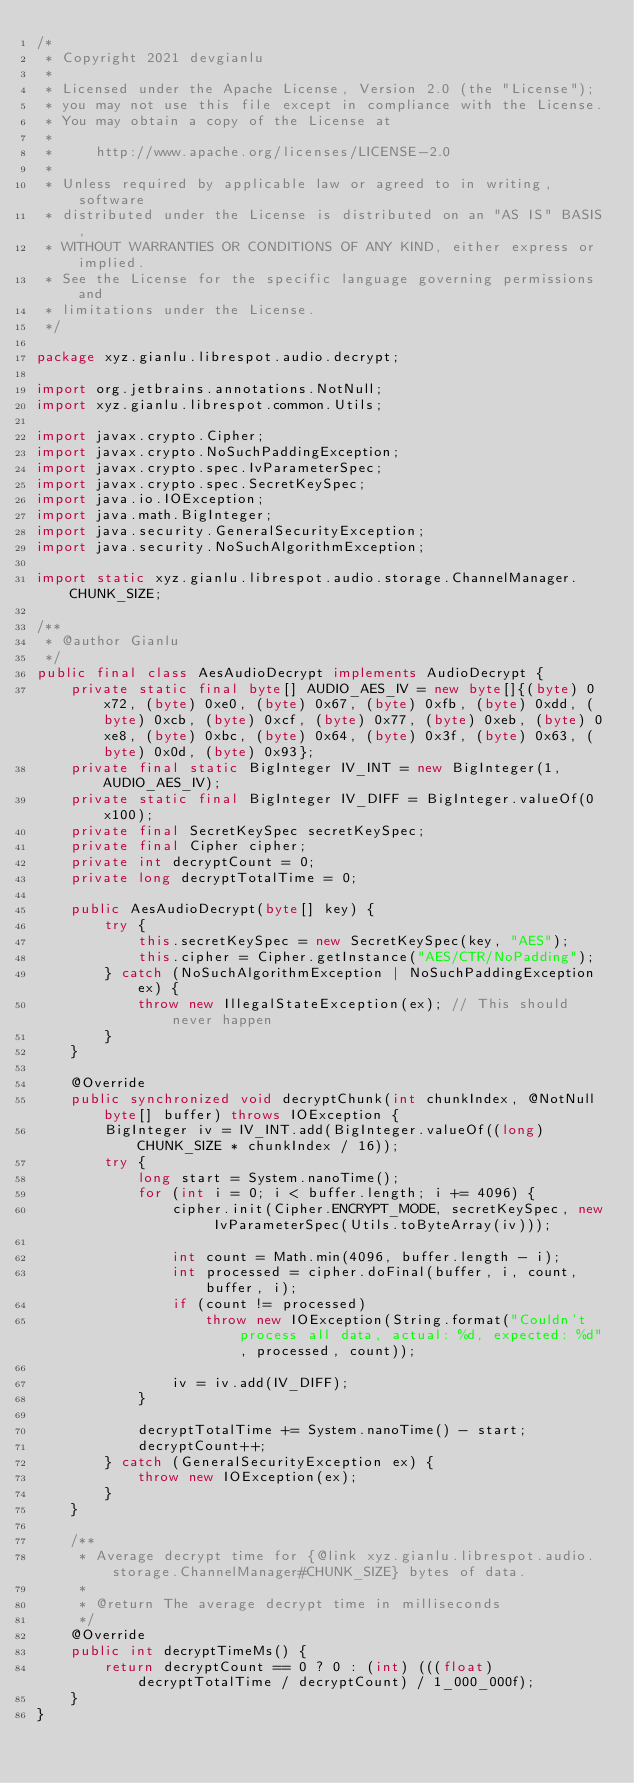<code> <loc_0><loc_0><loc_500><loc_500><_Java_>/*
 * Copyright 2021 devgianlu
 *
 * Licensed under the Apache License, Version 2.0 (the "License");
 * you may not use this file except in compliance with the License.
 * You may obtain a copy of the License at
 *
 *     http://www.apache.org/licenses/LICENSE-2.0
 *
 * Unless required by applicable law or agreed to in writing, software
 * distributed under the License is distributed on an "AS IS" BASIS,
 * WITHOUT WARRANTIES OR CONDITIONS OF ANY KIND, either express or implied.
 * See the License for the specific language governing permissions and
 * limitations under the License.
 */

package xyz.gianlu.librespot.audio.decrypt;

import org.jetbrains.annotations.NotNull;
import xyz.gianlu.librespot.common.Utils;

import javax.crypto.Cipher;
import javax.crypto.NoSuchPaddingException;
import javax.crypto.spec.IvParameterSpec;
import javax.crypto.spec.SecretKeySpec;
import java.io.IOException;
import java.math.BigInteger;
import java.security.GeneralSecurityException;
import java.security.NoSuchAlgorithmException;

import static xyz.gianlu.librespot.audio.storage.ChannelManager.CHUNK_SIZE;

/**
 * @author Gianlu
 */
public final class AesAudioDecrypt implements AudioDecrypt {
    private static final byte[] AUDIO_AES_IV = new byte[]{(byte) 0x72, (byte) 0xe0, (byte) 0x67, (byte) 0xfb, (byte) 0xdd, (byte) 0xcb, (byte) 0xcf, (byte) 0x77, (byte) 0xeb, (byte) 0xe8, (byte) 0xbc, (byte) 0x64, (byte) 0x3f, (byte) 0x63, (byte) 0x0d, (byte) 0x93};
    private final static BigInteger IV_INT = new BigInteger(1, AUDIO_AES_IV);
    private static final BigInteger IV_DIFF = BigInteger.valueOf(0x100);
    private final SecretKeySpec secretKeySpec;
    private final Cipher cipher;
    private int decryptCount = 0;
    private long decryptTotalTime = 0;

    public AesAudioDecrypt(byte[] key) {
        try {
            this.secretKeySpec = new SecretKeySpec(key, "AES");
            this.cipher = Cipher.getInstance("AES/CTR/NoPadding");
        } catch (NoSuchAlgorithmException | NoSuchPaddingException ex) {
            throw new IllegalStateException(ex); // This should never happen
        }
    }

    @Override
    public synchronized void decryptChunk(int chunkIndex, @NotNull byte[] buffer) throws IOException {
        BigInteger iv = IV_INT.add(BigInteger.valueOf((long) CHUNK_SIZE * chunkIndex / 16));
        try {
            long start = System.nanoTime();
            for (int i = 0; i < buffer.length; i += 4096) {
                cipher.init(Cipher.ENCRYPT_MODE, secretKeySpec, new IvParameterSpec(Utils.toByteArray(iv)));

                int count = Math.min(4096, buffer.length - i);
                int processed = cipher.doFinal(buffer, i, count, buffer, i);
                if (count != processed)
                    throw new IOException(String.format("Couldn't process all data, actual: %d, expected: %d", processed, count));

                iv = iv.add(IV_DIFF);
            }

            decryptTotalTime += System.nanoTime() - start;
            decryptCount++;
        } catch (GeneralSecurityException ex) {
            throw new IOException(ex);
        }
    }

    /**
     * Average decrypt time for {@link xyz.gianlu.librespot.audio.storage.ChannelManager#CHUNK_SIZE} bytes of data.
     *
     * @return The average decrypt time in milliseconds
     */
    @Override
    public int decryptTimeMs() {
        return decryptCount == 0 ? 0 : (int) (((float) decryptTotalTime / decryptCount) / 1_000_000f);
    }
}
</code> 